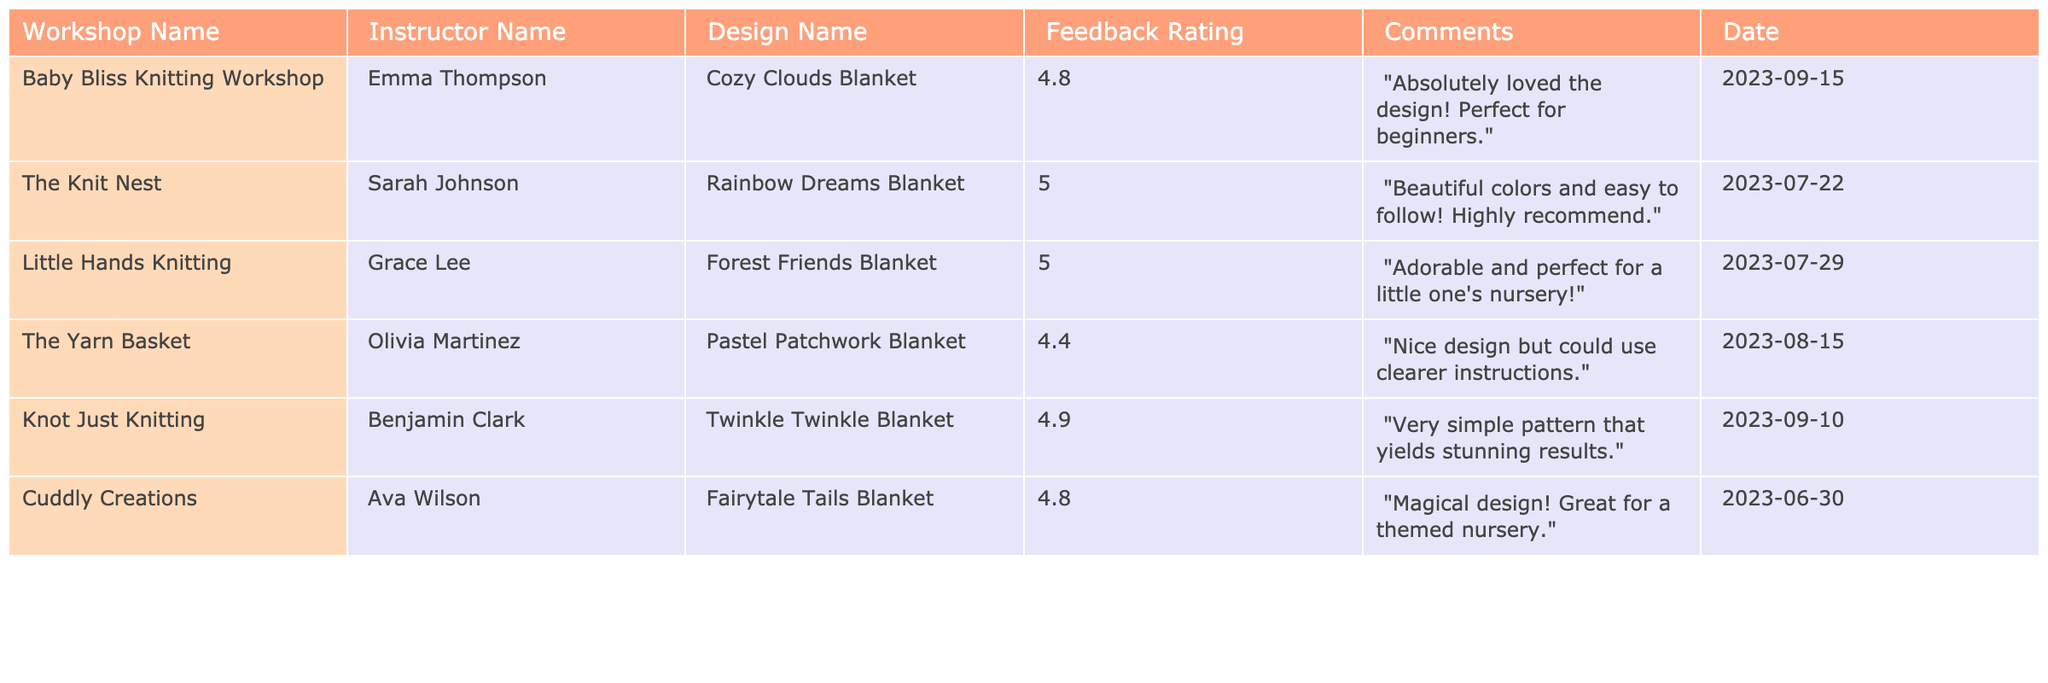What is the highest feedback rating among the blanket designs? The highest feedback rating in the table is 5.0, which is mentioned for both the Rainbow Dreams Blanket and the Forest Friends Blanket.
Answer: 5.0 Which workshop has the blanket design with the lowest feedback rating? The Pastel Patchwork Blanket from The Yarn Basket has the lowest feedback rating of 4.4 in the table.
Answer: The Yarn Basket How many different instructors are represented in the table? There are six different instructors listed in the table, each associated with a unique workshop and blanket design.
Answer: 6 What is the average feedback rating for all the blanket designs? Adding the ratings: 4.8 + 5.0 + 5.0 + 4.4 + 4.9 + 4.8 gives a sum of 29.9. There are 6 ratings, so the average is 29.9/6 = 4.9833, which rounds to approximately 4.98.
Answer: Approximately 4.98 Did any feedback comments mention ease of following the design? Yes, both the Rainbow Dreams Blanket and Twinkle Twinkle Blanket comments mention that the designs are easy to follow.
Answer: Yes Which design received a comment about being perfect for a nursery? The Forest Friends Blanket received a comment saying it is "adorable and perfect for a little one's nursery."
Answer: Forest Friends Blanket How many blanket designs received a feedback rating of 4.8 or higher? Counting the ratings, Cozy Clouds, Rainbow Dreams, Forest Friends, Twinkle Twinkle, and Fairytale Tails all received ratings of 4.8 or higher, making a total of 5 designs.
Answer: 5 Is there any design that has the theme of a nursery? Yes, both the Forest Friends Blanket, mentioned as perfect for a nursery, and the Fairytale Tails Blanket, which is also described as magical for a themed nursery, fit the theme.
Answer: Yes What date was the Pastel Patchwork Blanket workshop held? The workshop for the Pastel Patchwork Blanket was held on August 15, 2023.
Answer: August 15, 2023 Which instructor's design received the highest feedback rating, and what was it? Sarah Johnson's Rainbow Dreams Blanket received the highest feedback rating of 5.0.
Answer: Sarah Johnson, 5.0 